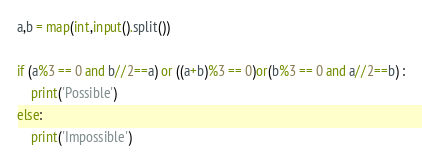Convert code to text. <code><loc_0><loc_0><loc_500><loc_500><_Python_>a,b = map(int,input().split())

if (a%3 == 0 and b//2==a) or ((a+b)%3 == 0)or(b%3 == 0 and a//2==b) :
    print('Possible')
else:
    print('Impossible')</code> 